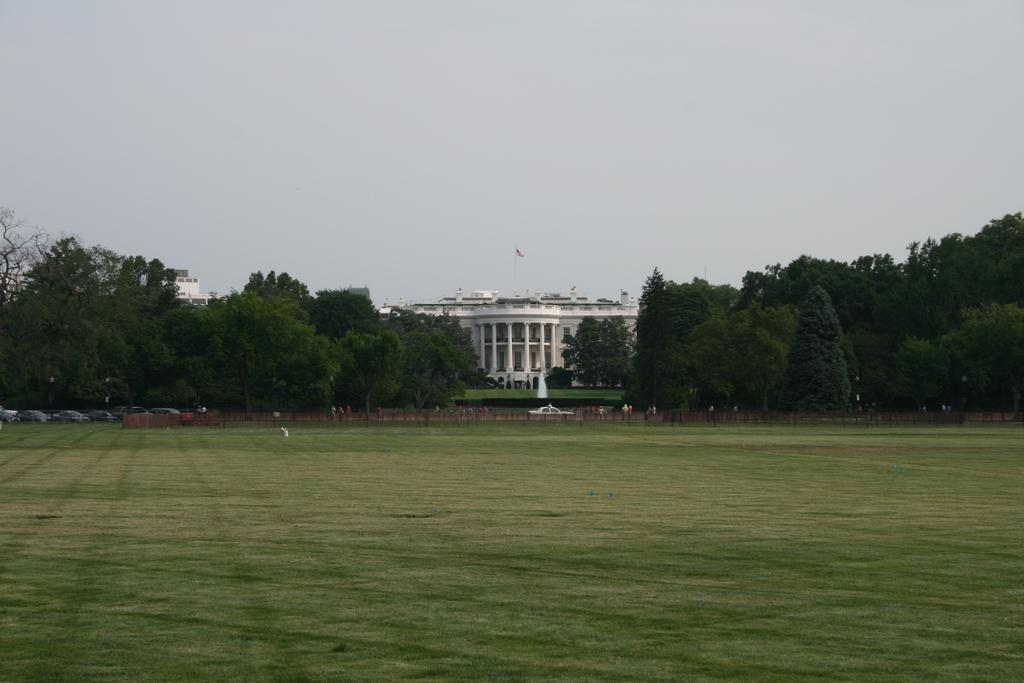What type of surface is at the bottom of the image? There is grass on the ground at the bottom of the image. What can be seen in the distance in the image? There are vehicles, poles, people, trees, buildings, and a flag on a building in the background of the image. What is visible in the sky in the image? The sky is visible in the background of the image. What thoughts are the girls having while looking at the flag in the image? There are no girls present in the image, so it is not possible to determine their thoughts or actions. 